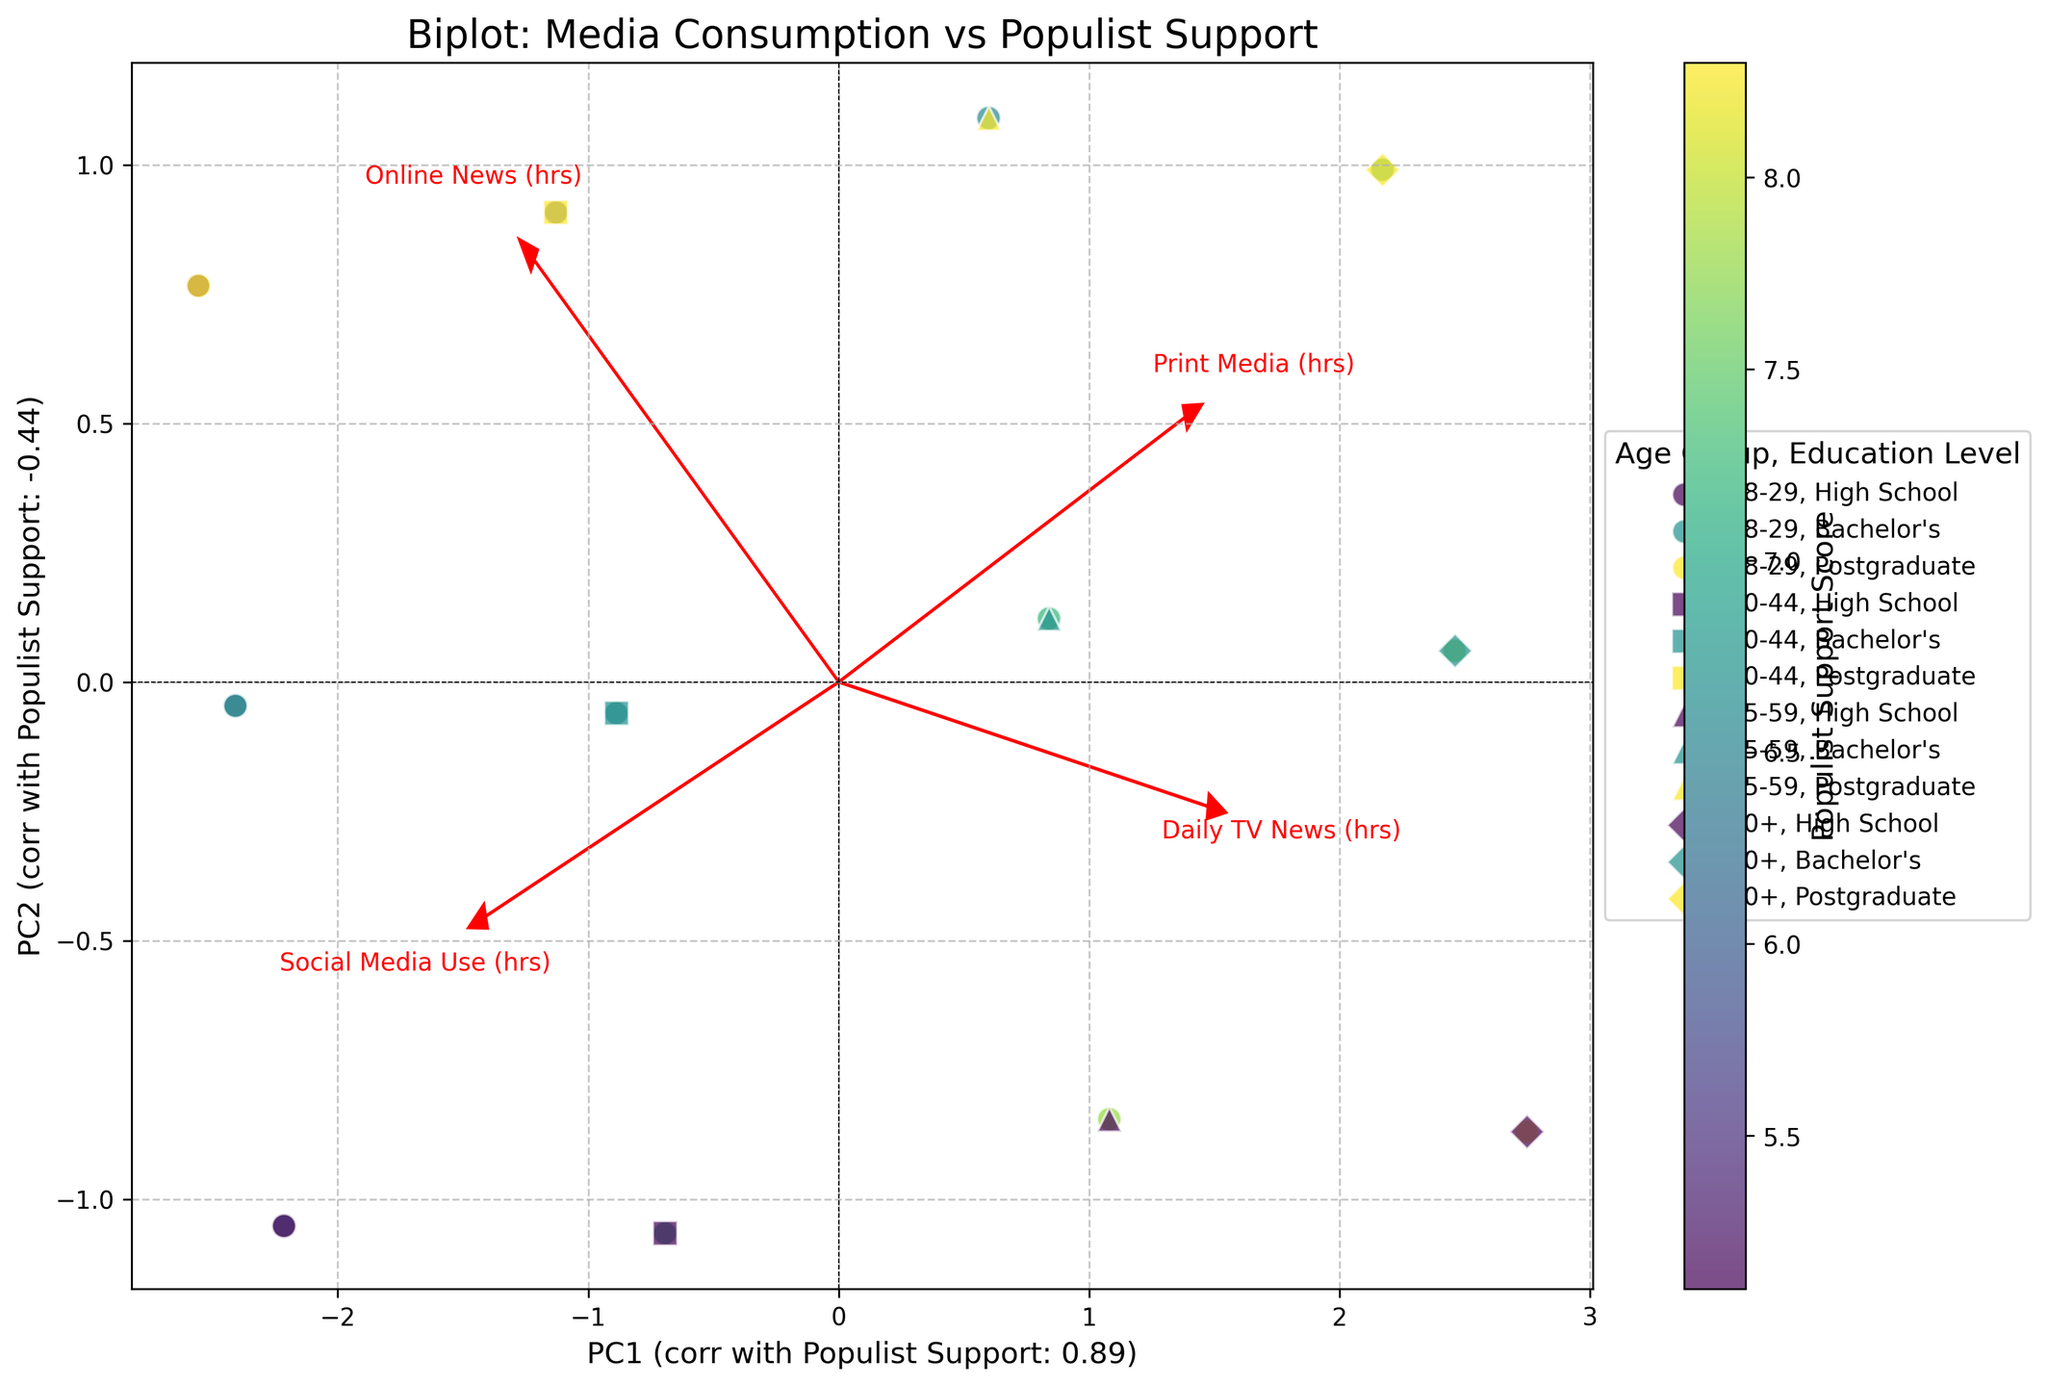What are the axes representing in this biplot? The axes in the biplot represent the first two principal components (PC1 and PC2). The labels of these axes also indicate their correlation with the Populist Support Score.
Answer: The first two principal components What does the color gradient in the scatter plot indicate? The color gradient in the scatter plot indicates the Populist Support Score, where different colors represent varying levels of support for populist movements.
Answer: Populist Support Score Which media consumption behavior vector is longest in the biplot? By looking at the red arrows representing the media consumption behaviors, the vector for 'Daily TV News (hrs)' appears to be the longest, indicating it has the most significant correlation with the principal components.
Answer: Daily TV News (hrs) How does 'Daily TV News (hrs)' relate to Populist Support Score, as indicated in the plot? The 'Daily TV News (hrs)' vector has a positive direction towards higher Populist Support Scores, indicating that higher consumption of daily TV news is correlated with higher Populist Support Scores.
Answer: Positively correlated What can be inferred about the age group 60+ with high school education level based on their position in the plot? The age group 60+ with a high school education level is positioned in the upper-right quadrant of the plot, indicating higher populist support scores and higher values for 'Daily TV News (hrs)' and 'Print Media (hrs)'.
Answer: Higher populist support, higher TV news and print media consumption Which media consumption behavior shows the least variation among different age and education groups? The 'Social Media Use (hrs)' vector is the shortest, suggesting that it has less variation and a weaker correlation with the principal components among the different age and education groups.
Answer: Social Media Use (hrs) How does the plot illustrate the difference in populist support between high school graduates and postgraduates in the 18-29 age group? Points representing high school graduates in the 18-29 age group are in areas indicating higher Populist Support Scores, while postgraduates in the same age group are in lower score regions, showing a higher populist support for high school graduates.
Answer: Higher populist support for high school graduates Do younger age groups show higher or lower Populist Support Scores compared to older age groups across different education levels? By comparing the color gradient of points of age groups, younger age groups (e.g., 18-29) generally show lower Populist Support Scores, while older age groups (e.g., 60+) show higher scores, regardless of education levels.
Answer: Younger age groups have lower populist support scores Which principal component correlates more strongly with the Populist Support Score? The x-axis (PC1) has a correlation coefficient more significant with the Populist Support Score than the y-axis (PC2). This is derived from the axis label showing correlation values.
Answer: PC1 